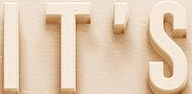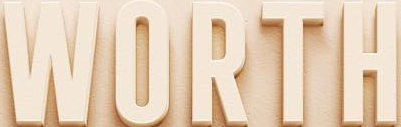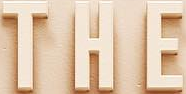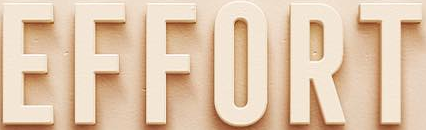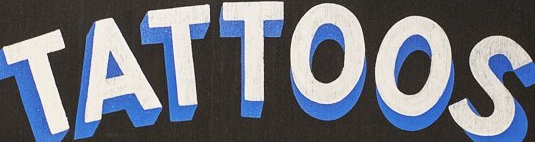Identify the words shown in these images in order, separated by a semicolon. IT'S; WORTH; THE; EFFORT; TATTOOS 